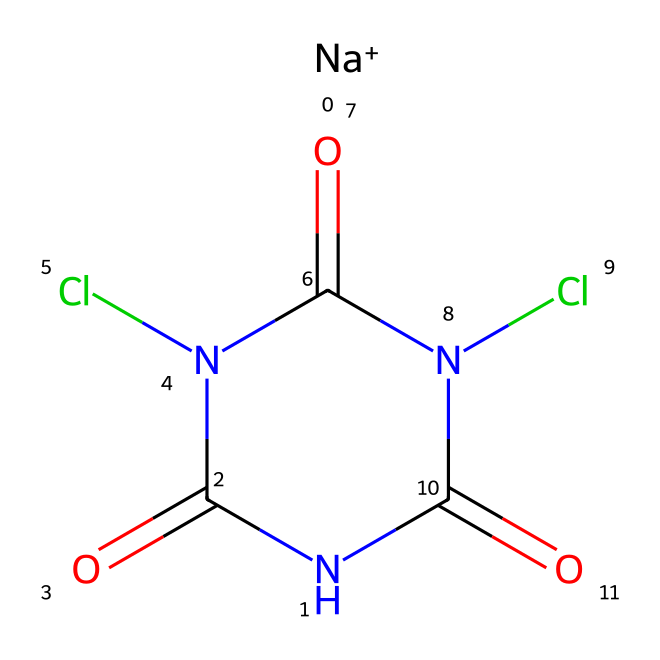What is the valence of sodium in this compound? Sodium typically has a valence of +1, as indicated by the [Na+] in the SMILES representation, which shows its ionized state.
Answer: +1 How many nitrogen atoms are present in this compound? The structure shows two nitrogen atoms as indicated by the two nitrogen symbols (N) in the chemical structure.
Answer: 2 What is the total number of carbon atoms in the molecule? The SMILES representation contains four carbon atoms (C), as seen in the chain and the cyclic structure.
Answer: 4 What type of chemical structure does this compound represent? This compound contains a cyclic structure as indicated by "N1(...C1=O)" which shows that the nitrogen is part of a ring, making it a cyclic compound.
Answer: cyclic Which part of this chemical structure indicates it has potential disinfection properties? The presence of chlorine atoms (represented by "Cl") is often associated with disinfection, as chlorine is commonly used as a disinfectant in water purification.
Answer: chlorine What functional groups are present in the molecule? The molecule includes amide groups (due to the N(Cl)C(=O) parts), which are typical in certain water purification agents.
Answer: amide 